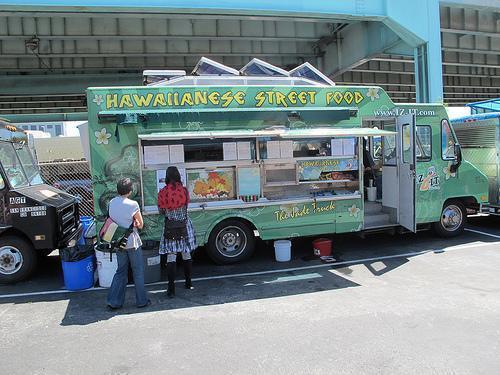How many people are in the picture?
Give a very brief answer. 2. 